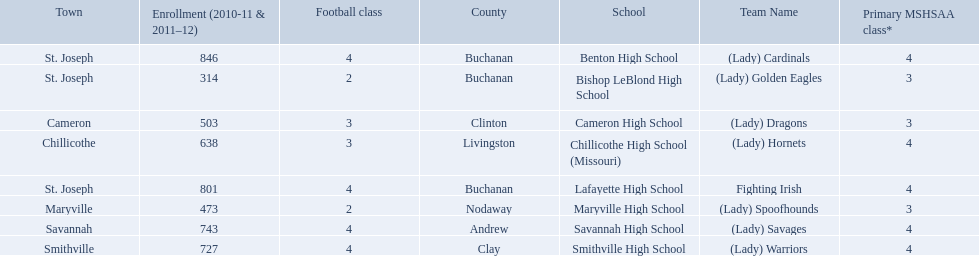What are all of the schools? Benton High School, Bishop LeBlond High School, Cameron High School, Chillicothe High School (Missouri), Lafayette High School, Maryville High School, Savannah High School, Smithville High School. How many football classes do they have? 4, 2, 3, 3, 4, 2, 4, 4. What about their enrollment? 846, 314, 503, 638, 801, 473, 743, 727. Which schools have 3 football classes? Cameron High School, Chillicothe High School (Missouri). And of those schools, which has 638 students? Chillicothe High School (Missouri). What are the names of the schools? Benton High School, Bishop LeBlond High School, Cameron High School, Chillicothe High School (Missouri), Lafayette High School, Maryville High School, Savannah High School, Smithville High School. Of those, which had a total enrollment of less than 500? Bishop LeBlond High School, Maryville High School. And of those, which had the lowest enrollment? Bishop LeBlond High School. 